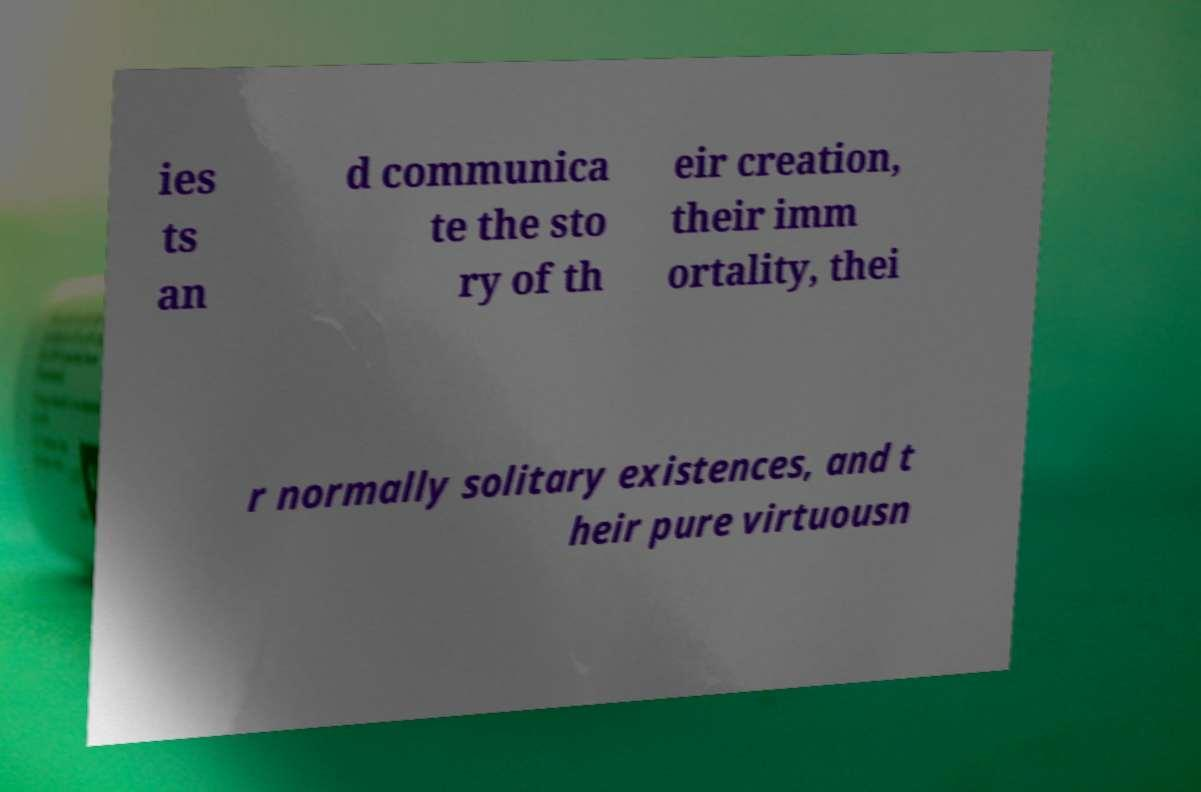What messages or text are displayed in this image? I need them in a readable, typed format. ies ts an d communica te the sto ry of th eir creation, their imm ortality, thei r normally solitary existences, and t heir pure virtuousn 